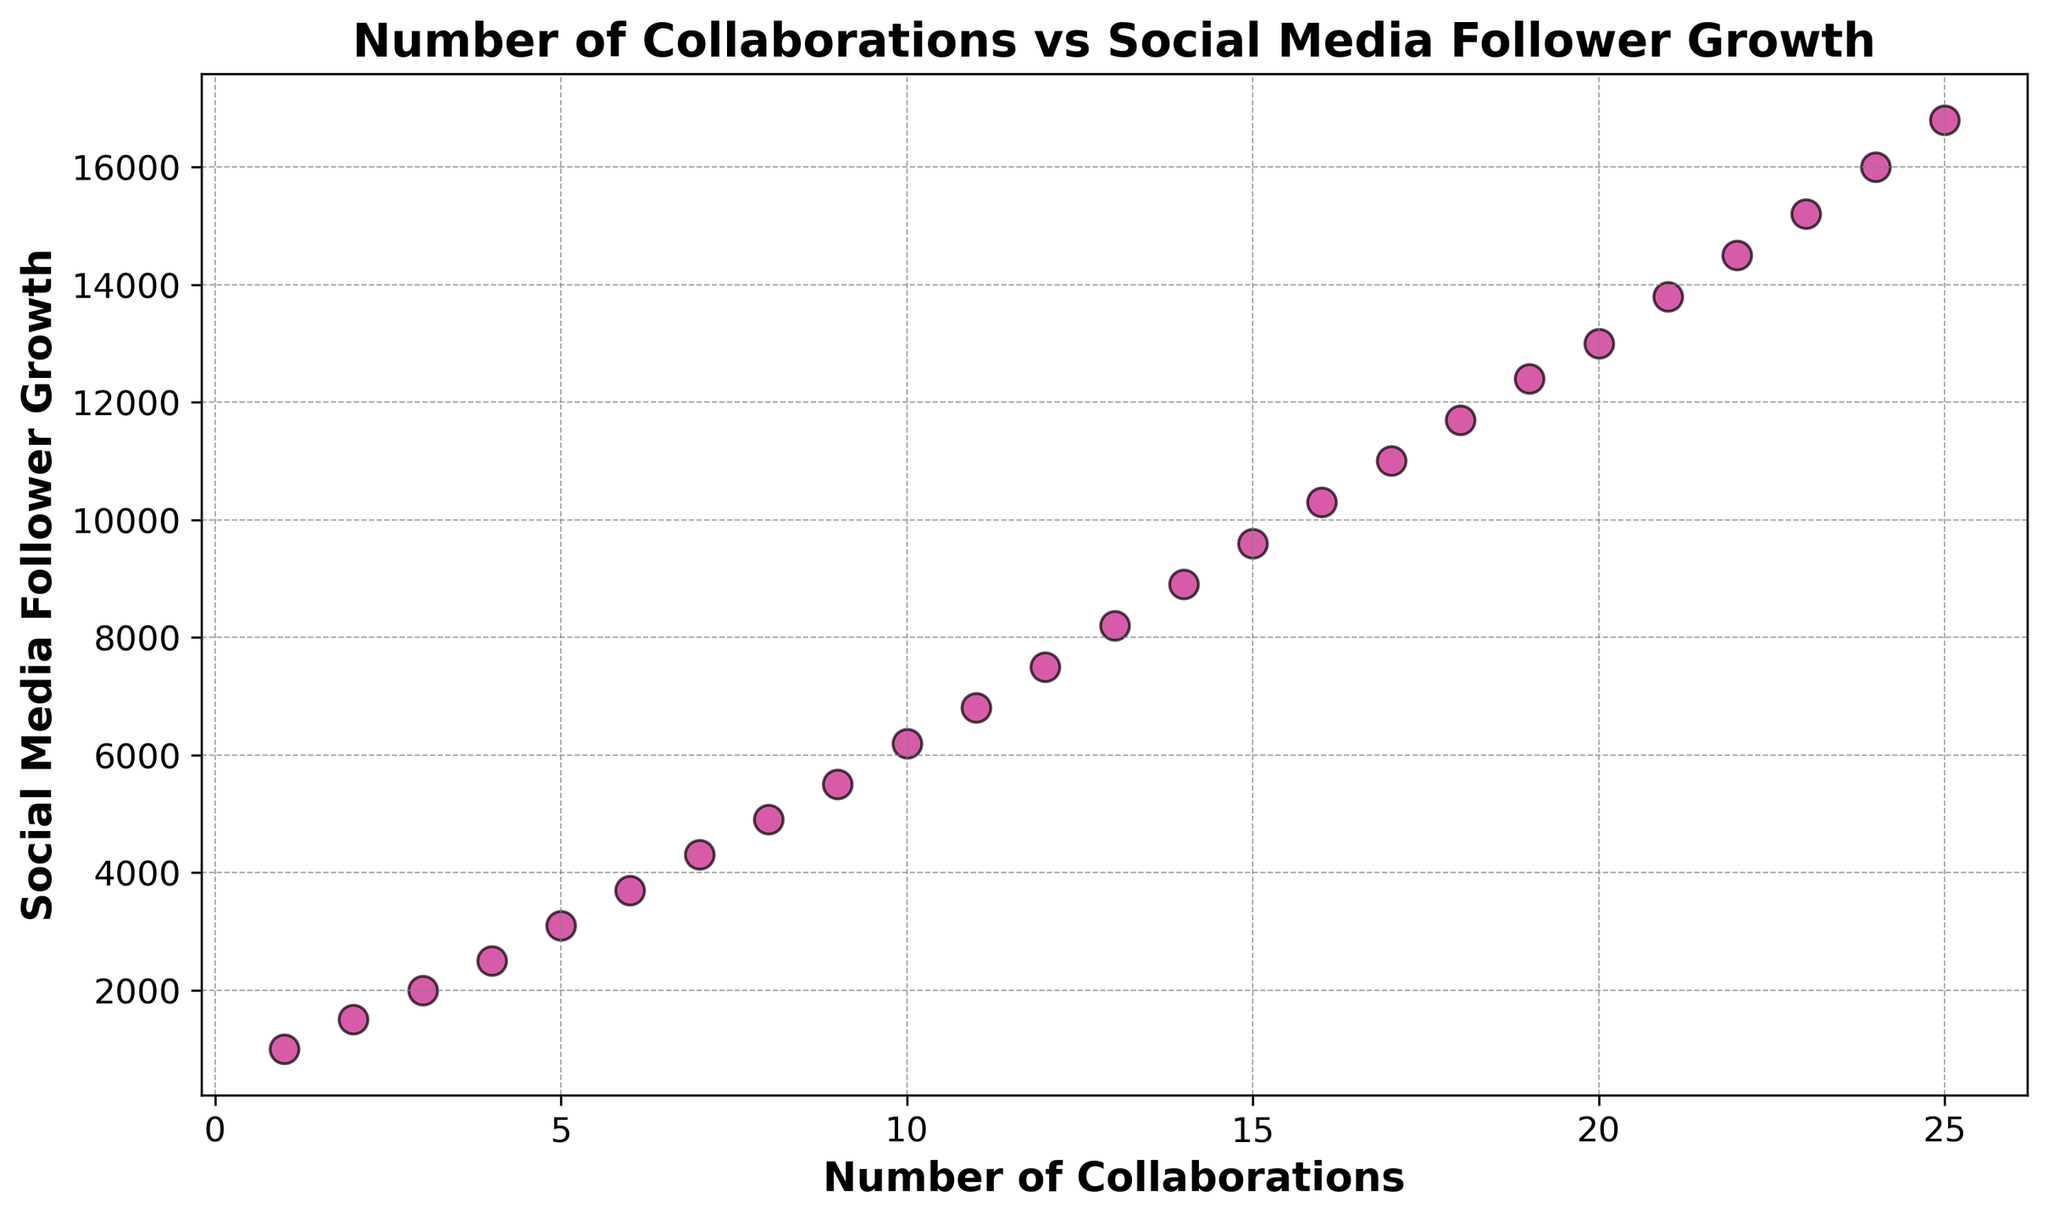What's the range of social media follower growth represented in the plot? To determine the range, we find the minimum and maximum values of social media follower growth on the y-axis. The minimum value is 1000, and the maximum value is 16800. So, the range is 16800 - 1000.
Answer: 15800 As the number of collaborations increases, does social media follower growth generally increase, decrease, or stay the same? Observing the trend as the number of collaborations increases from 1 to 25, there is a general trend of increasing social media follower growth, as evidenced by the upward slope in the scatter plot.
Answer: Increase What is the social media follower growth for the band with 10 collaborations? Locate the point corresponding to 10 collaborations on the x-axis and read the y-value at this point. The y-value is 6200.
Answer: 6200 Which collaboration count corresponds to the second highest social media follower growth? The second highest social media follower growth is 16000. Locate this point on the y-axis and find the corresponding x-value, which is 24 collaborations.
Answer: 24 Is there a clear linear relationship between the number of collaborations and social media follower growth? By visually assessing the scatter plot, we notice a consistent upward trend where social media follower growth increases as the number of collaborations increases, indicating a clear linear relationship.
Answer: Yes What is the approximate average social media follower growth for bands with 5 and 15 collaborations? Locate the points for 5 (3100) and 15 (9600) collaborations and find their average: (3100 + 9600) / 2 = 6350.
Answer: 6350 Which band with fewer than 10 collaborations has achieved the highest social media follower growth? Look at the points on the scatter plot with x-values less than 10 and identify the highest y-value, which is 5500 for 9 collaborations.
Answer: 9 collaborations Comparing the bands with 8 and 18 collaborations, which has higher social media follower growth? Locate the points for 8 (4900) and 18 (11700) collaborations. The band with 18 collaborations has higher follower growth.
Answer: 18 collaborations For which value of collaborations does the social media follower growth reach 10300? Locate the y-value of 10300 on the scatter plot and identify the corresponding x-value, which is 16 collaborations.
Answer: 16 collaborations 